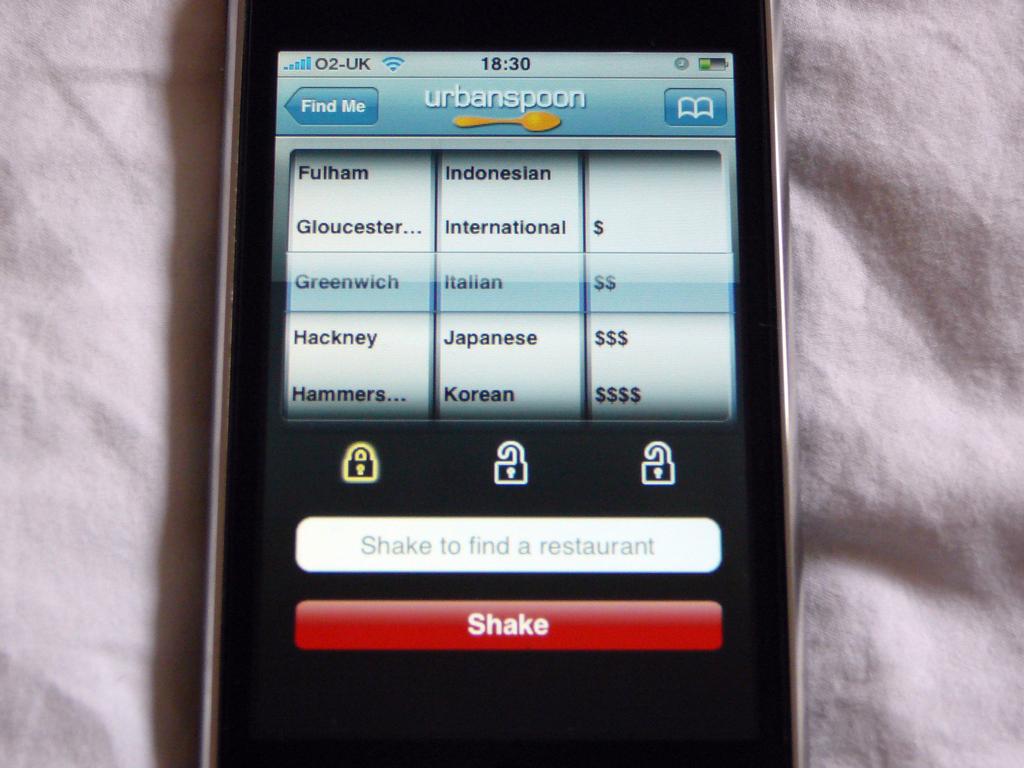What is the name of the open app?
Give a very brief answer. Urbanspoon. What time is it on the phone?
Give a very brief answer. 18:30. 